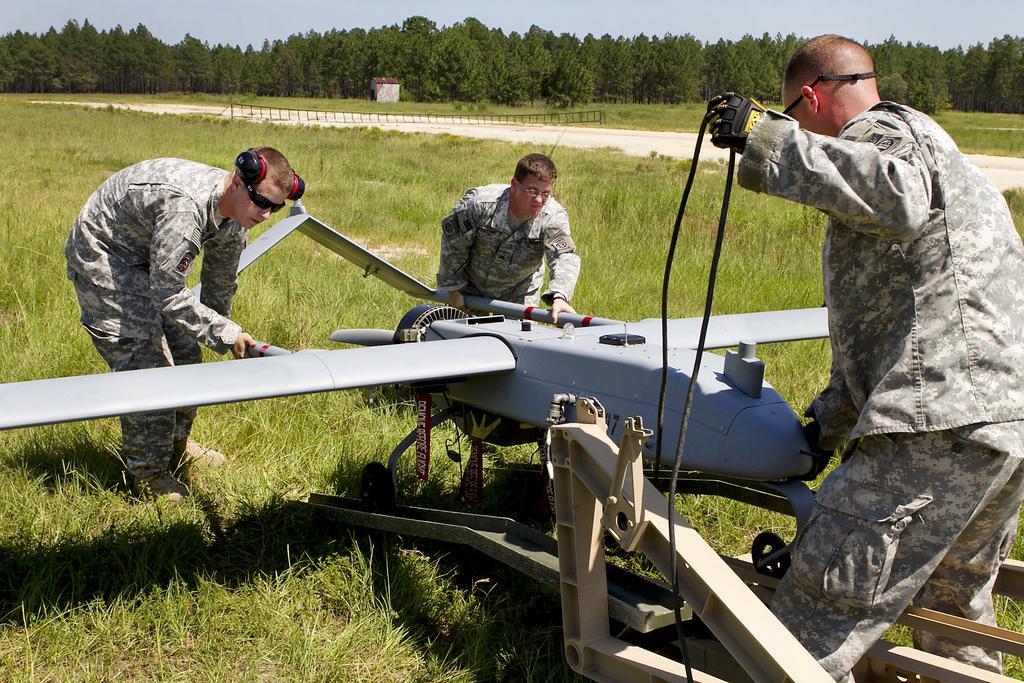Please provide a concise description of this image. In this picture there is a small aircraft toy in the grass field. Beside there are three military boys around the aircraft. Behind there is a grass field and some trees in the background. 